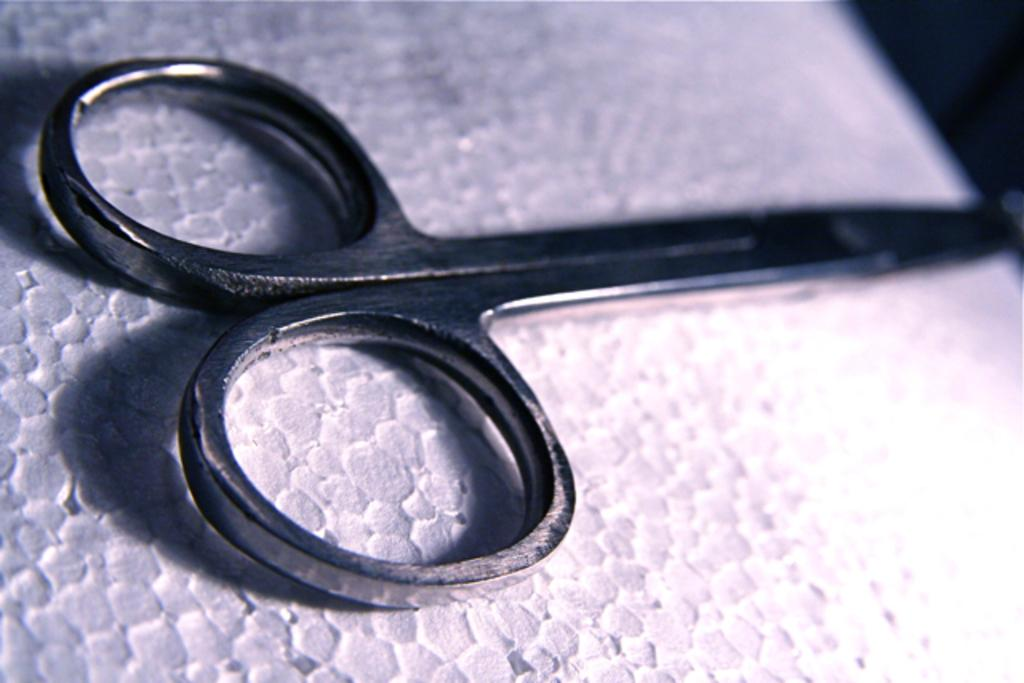What object is located at the front of the image? There are scissors in the front of the image. What is the scissors positioned near in the image? The scissors are near a paper at the bottom of the image. What type of breakfast is being prepared in the image? There is no breakfast or any indication of food preparation in the image; it only features scissors and a paper. 